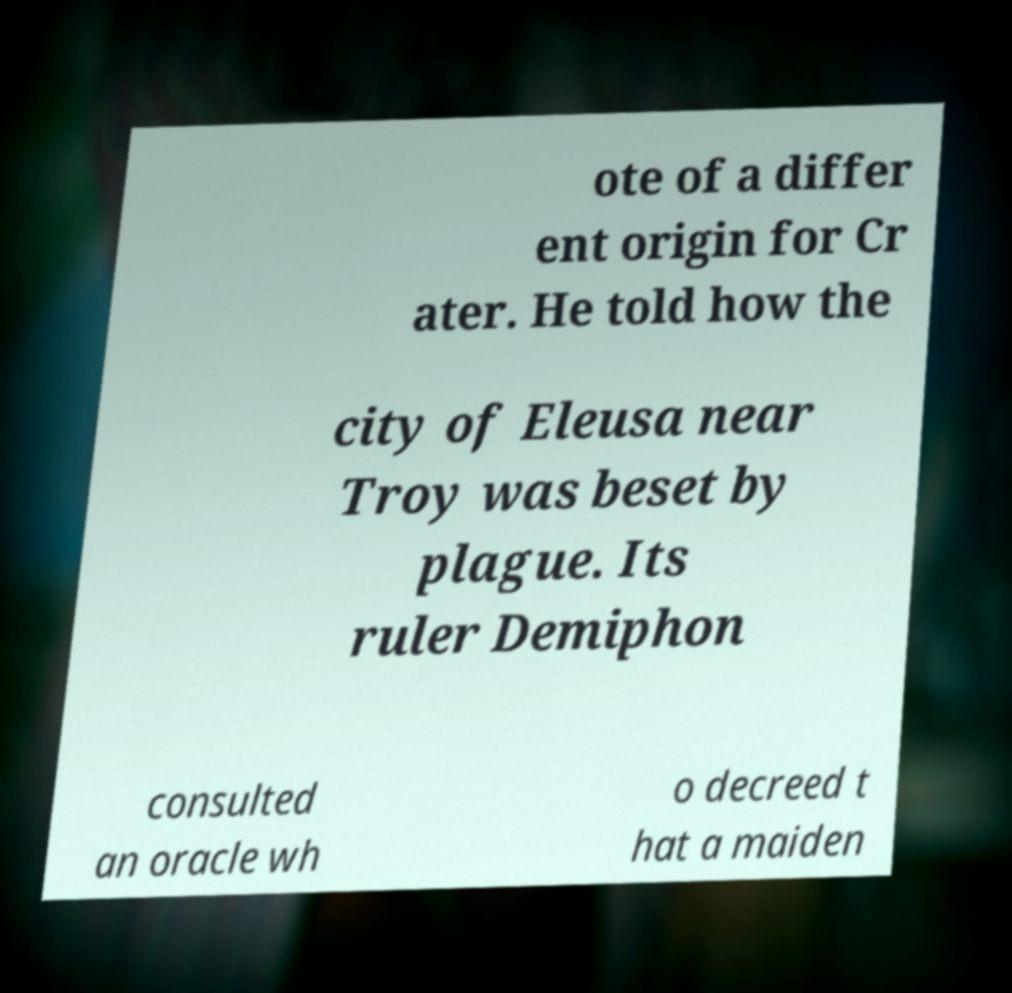Could you extract and type out the text from this image? ote of a differ ent origin for Cr ater. He told how the city of Eleusa near Troy was beset by plague. Its ruler Demiphon consulted an oracle wh o decreed t hat a maiden 